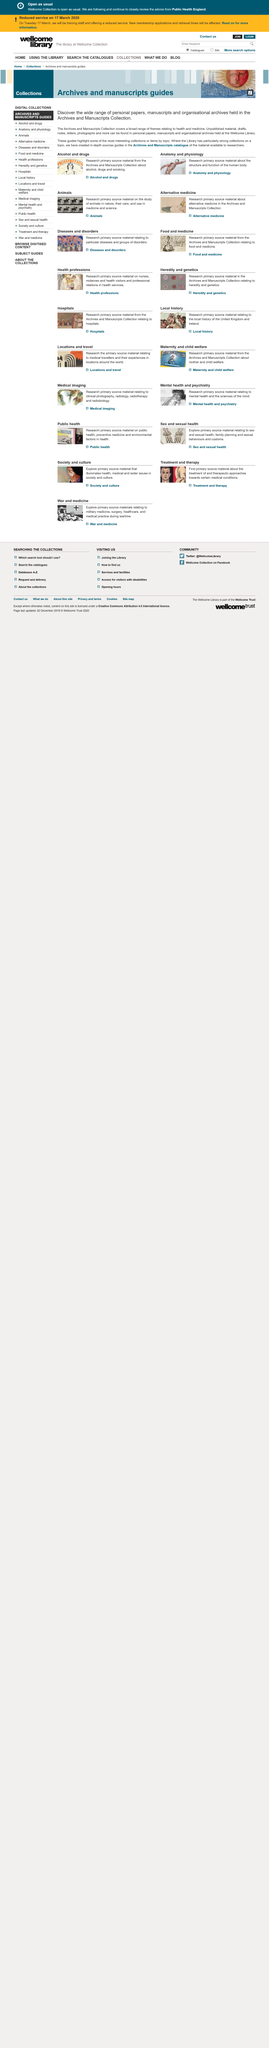Identify some key points in this picture. The archives and manuscripts collection holds a wide range of personal papers, manuscripts, and organizational archives. The Wellcome Library holds a vast array of unpublished materials, including drafts, notes, letters, and photographs, which can be found in its personal papers, manuscripts, and organizational archives. The archives and manuscripts collection covers a broad range of themes related to health and medicine. 